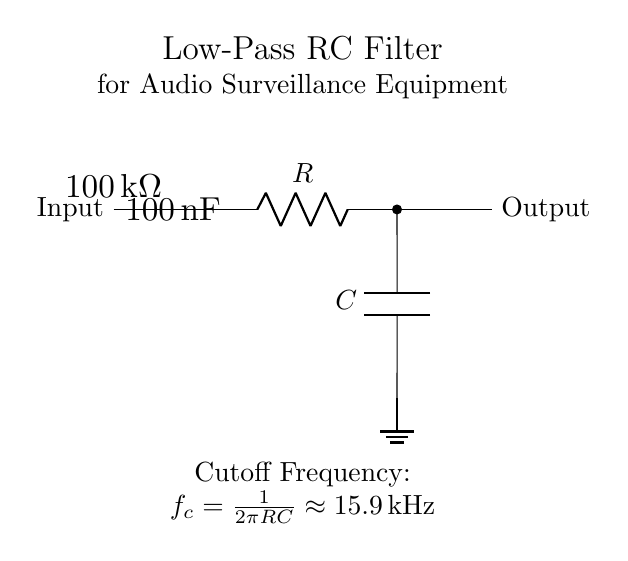What type of filter is used in this circuit? The circuit uses a low-pass filter, which allows low-frequency signals to pass through while attenuating higher frequencies. This is indicated by the configuration of the resistor and capacitor in series, and their connection to ground.
Answer: Low-pass filter What is the resistance value in this circuit? The resistor value is specified in the circuit as one hundred kilo-ohms, which affects the overall filtering properties of the circuit together with the capacitor.
Answer: One hundred kilo-ohms What is the cutoff frequency of this filter? The cutoff frequency, which is the frequency at which the output signal power drops to half its value, is calculated as one divided by two times pi times the resistance value times the capacitance value, yielding approximately 15.9 kilohertz.
Answer: Approximately 15.9 kilohertz What happens to noise frequencies above the cutoff? Frequencies above the cutoff frequency are attenuated, meaning they are reduced in amplitude as they pass through the filter, which helps to clean up the audio signal by reducing unwanted noise.
Answer: Attenuated How is the capacitor oriented in the circuit? The capacitor is oriented with one terminal connected to the output of the resistor and the other terminal connected to ground, which is essential for its function in the low-pass filter design.
Answer: Connected to output and ground 